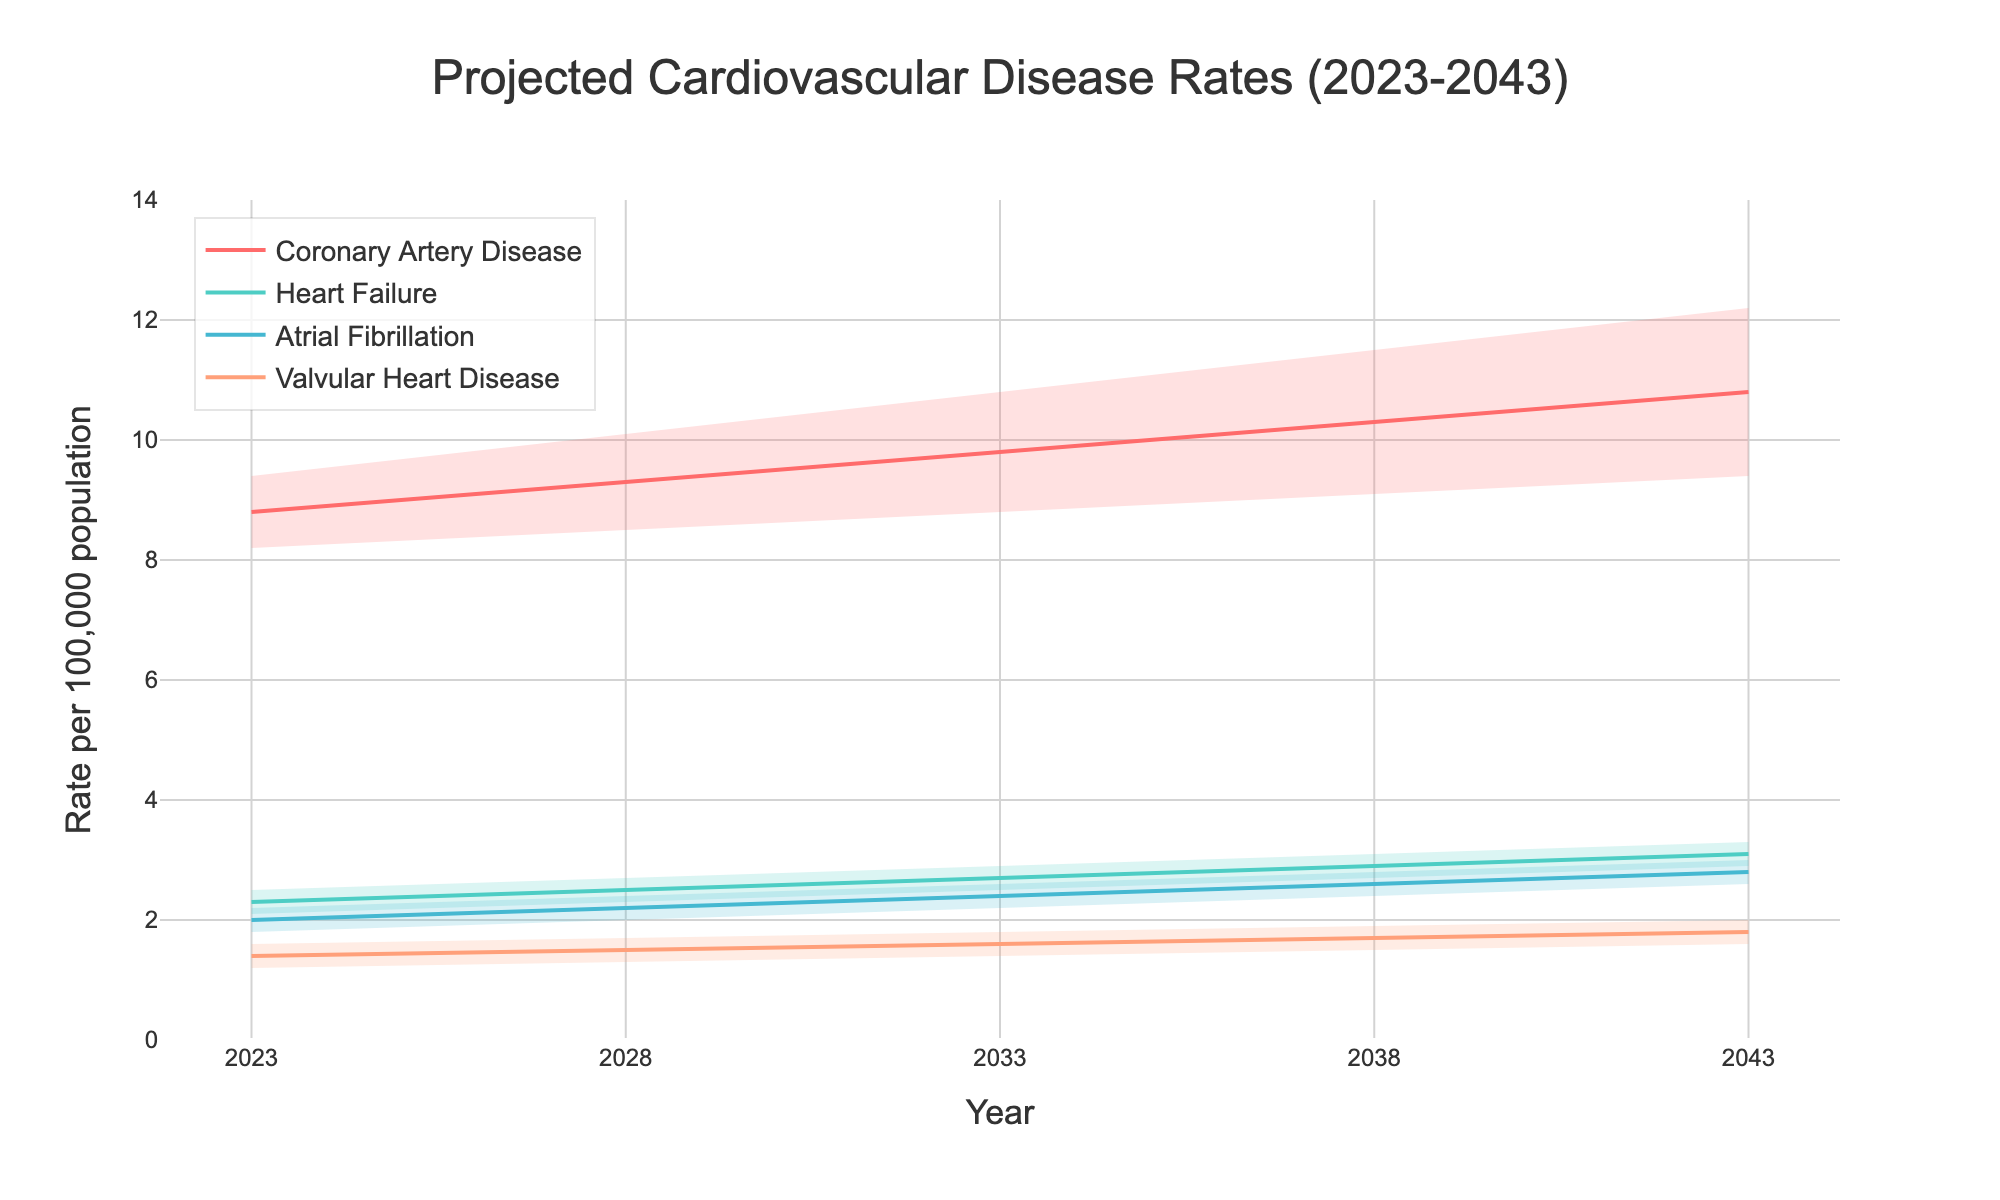What is the title of the figure? The title is located at the top of the chart, usually in a larger font size to catch the viewer's attention. By reading this text, we can determine the overall topic of the figure.
Answer: Projected Cardiovascular Disease Rates (2023-2043) How many heart conditions are displayed in the chart? By observing the different lines or labels in the legend of the chart, we can count the number of distinct heart conditions.
Answer: 4 What does the y-axis represent? The y-axis title provides a description of what is being measured vertically in the chart. Reading the y-axis label will give us this information.
Answer: Rate per 100,000 population What is the median projected rate for Coronary Artery Disease in 2043? Locate the line representing Coronary Artery Disease and find its value on the y-axis for the year 2043. This can be read directly from the chart.
Answer: 10.8 By how much is the upper projection of Heart Failure expected to increase from 2023 to 2043? Find the values of the upper projection for Heart Failure in 2023 and 2043 from the chart. Subtract the 2023 value from the 2043 value to get the increase.
Answer: 0.8 Which heart condition has the lowest projected median rate in 2043? Compare the median rates of all heart conditions for the year 2043 and identify the lowest one.
Answer: Valvular Heart Disease How does the median rate of Atrial Fibrillation change from 2023 to 2033? Locate the median rates for Atrial Fibrillation in 2023 and 2033 from the chart. Subtract the 2023 value from the 2033 value to determine the change.
Answer: Increases by 0.4 What is the range of the projected rates for Coronary Artery Disease in 2038? Identify the lower and upper projections for Coronary Artery Disease in 2038 from the chart. The range is the difference between these two values.
Answer: 2.4 Which heart condition shows the biggest projected increase in its median rate from 2023 to 2043? Calculate the change in median rate for all heart conditions between 2023 and 2043, and compare these changes to identify the largest one.
Answer: Coronary Artery Disease Are there any heart conditions for which the lower projection is below 2.0 in 2043? Look at the lower projections for all heart conditions in 2043 to check if any are below 2.0.
Answer: No 